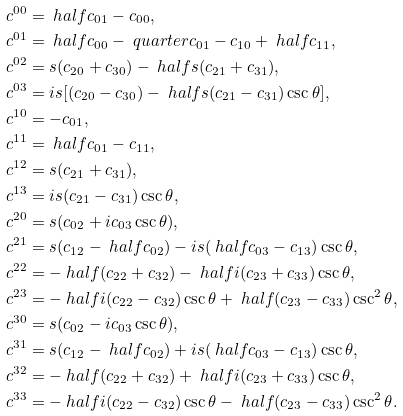Convert formula to latex. <formula><loc_0><loc_0><loc_500><loc_500>c ^ { 0 0 } & = \ h a l f c _ { 0 1 } - c _ { 0 0 } , \\ c ^ { 0 1 } & = \ h a l f c _ { 0 0 } - \ q u a r t e r c _ { 0 1 } - c _ { 1 0 } + \ h a l f c _ { 1 1 } , \\ c ^ { 0 2 } & = s ( c _ { 2 0 } + c _ { 3 0 } ) - \ h a l f s ( c _ { 2 1 } + c _ { 3 1 } ) , \\ c ^ { 0 3 } & = i s [ ( c _ { 2 0 } - c _ { 3 0 } ) - \ h a l f s ( c _ { 2 1 } - c _ { 3 1 } ) \csc \theta ] , \\ c ^ { 1 0 } & = - c _ { 0 1 } , \\ c ^ { 1 1 } & = \ h a l f c _ { 0 1 } - c _ { 1 1 } , \\ c ^ { 1 2 } & = s ( c _ { 2 1 } + c _ { 3 1 } ) , \\ c ^ { 1 3 } & = i s ( c _ { 2 1 } - c _ { 3 1 } ) \csc \theta , \\ c ^ { 2 0 } & = s ( c _ { 0 2 } + i c _ { 0 3 } \csc \theta ) , \\ c ^ { 2 1 } & = s ( c _ { 1 2 } - \ h a l f c _ { 0 2 } ) - i s ( \ h a l f c _ { 0 3 } - c _ { 1 3 } ) \csc \theta , \\ c ^ { 2 2 } & = - \ h a l f ( c _ { 2 2 } + c _ { 3 2 } ) - \ h a l f i ( c _ { 2 3 } + c _ { 3 3 } ) \csc \theta , \\ c ^ { 2 3 } & = - \ h a l f i ( c _ { 2 2 } - c _ { 3 2 } ) \csc \theta + \ h a l f ( c _ { 2 3 } - c _ { 3 3 } ) \csc ^ { 2 } \theta , \\ c ^ { 3 0 } & = s ( c _ { 0 2 } - i c _ { 0 3 } \csc \theta ) , \\ c ^ { 3 1 } & = s ( c _ { 1 2 } - \ h a l f c _ { 0 2 } ) + i s ( \ h a l f c _ { 0 3 } - c _ { 1 3 } ) \csc \theta , \\ c ^ { 3 2 } & = - \ h a l f ( c _ { 2 2 } + c _ { 3 2 } ) + \ h a l f i ( c _ { 2 3 } + c _ { 3 3 } ) \csc \theta , \\ c ^ { 3 3 } & = - \ h a l f i ( c _ { 2 2 } - c _ { 3 2 } ) \csc \theta - \ h a l f ( c _ { 2 3 } - c _ { 3 3 } ) \csc ^ { 2 } \theta . \\</formula> 